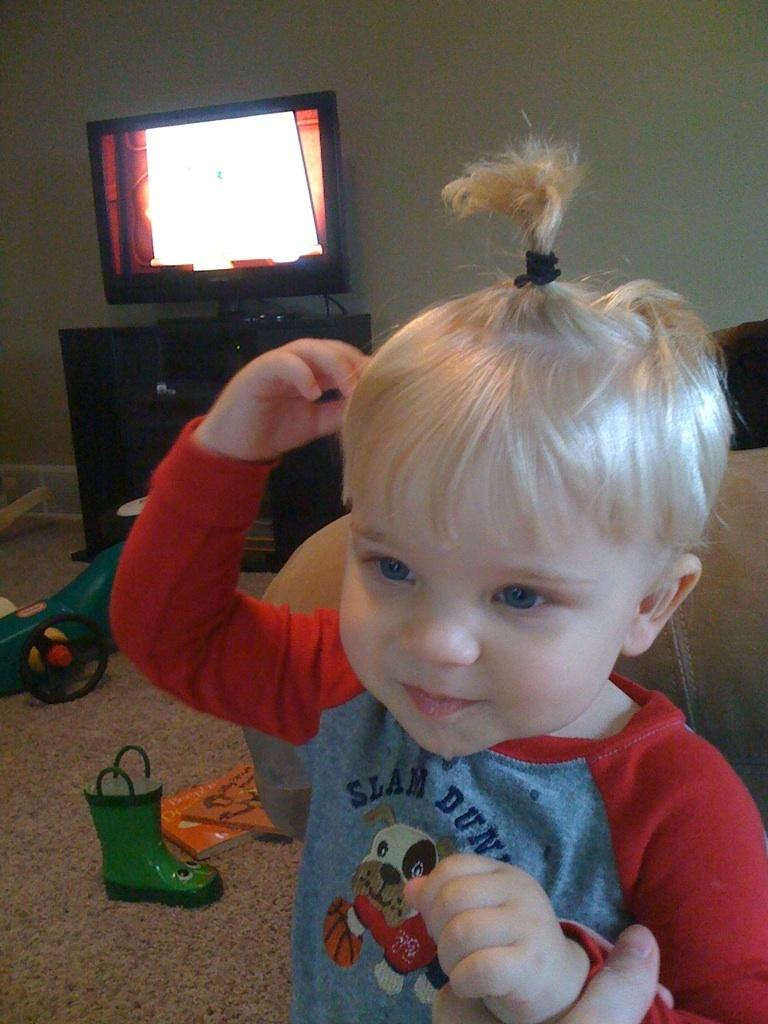What is the person in the image doing with the kid? The person is holding a kid in the image. What can be seen in the background of the image? There is a monitor on a stand and a couch in the background of the image. What is on the floor in the background of the image? There are objects on the floor in the background of the image. How does the person in the image perform division with the kid? There is no indication of performing division in the image; the person is simply holding the kid. Can you see any sheep in the image? There are no sheep present in the image. 